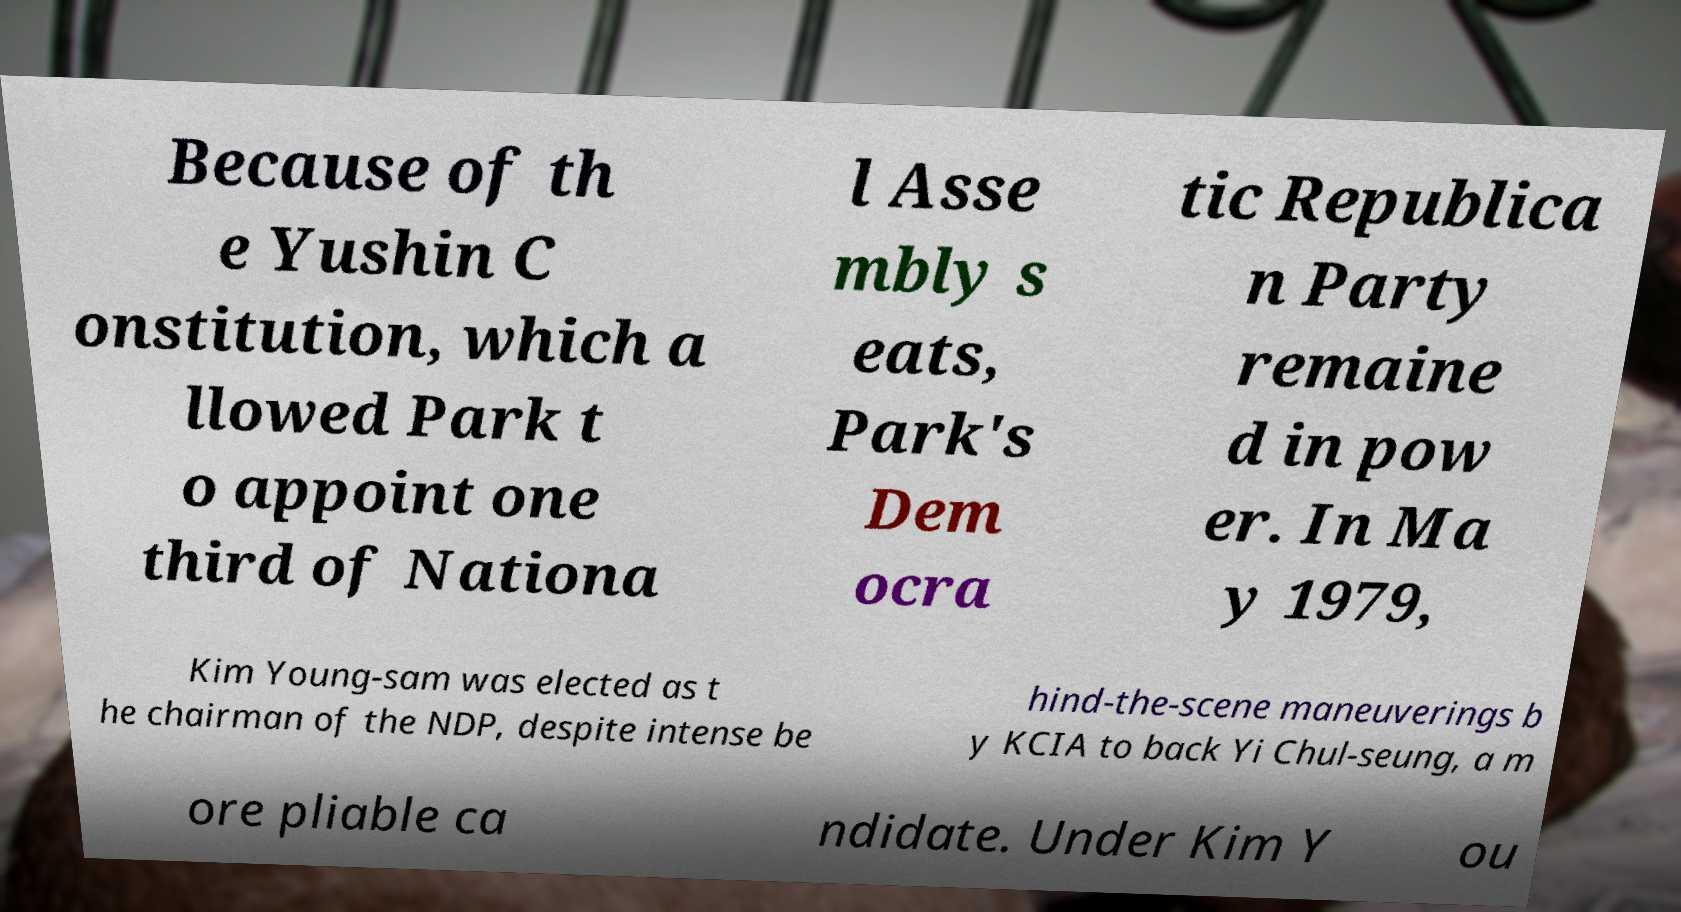Could you assist in decoding the text presented in this image and type it out clearly? Because of th e Yushin C onstitution, which a llowed Park t o appoint one third of Nationa l Asse mbly s eats, Park's Dem ocra tic Republica n Party remaine d in pow er. In Ma y 1979, Kim Young-sam was elected as t he chairman of the NDP, despite intense be hind-the-scene maneuverings b y KCIA to back Yi Chul-seung, a m ore pliable ca ndidate. Under Kim Y ou 